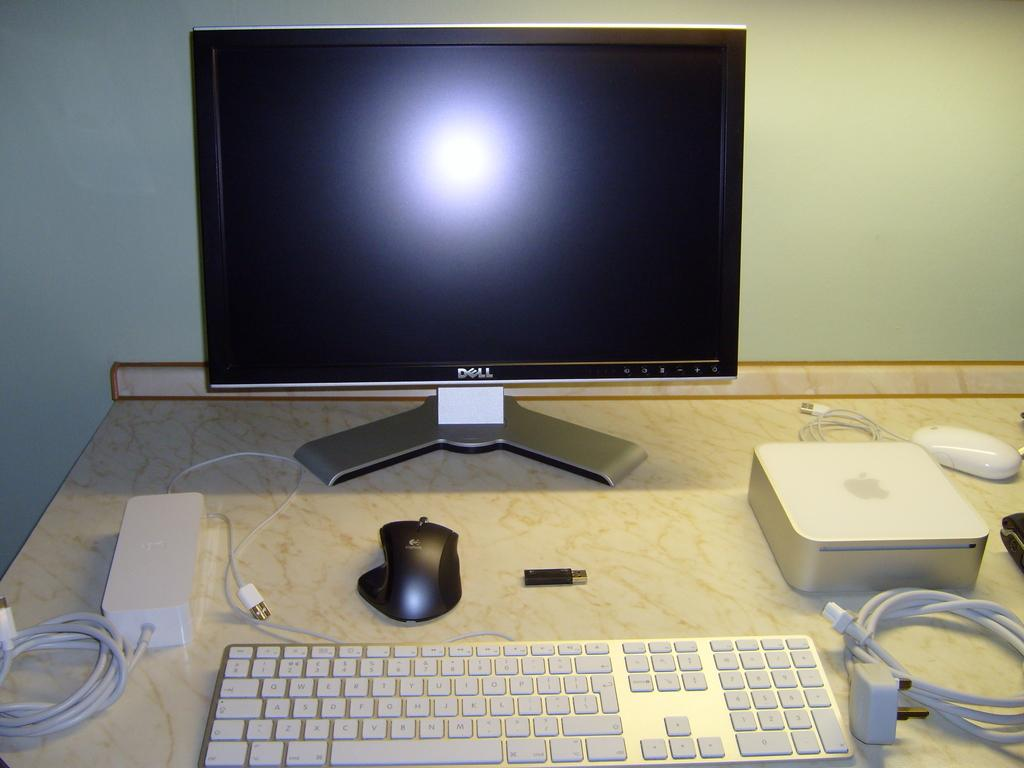<image>
Describe the image concisely. A keyboard, mouse and other computer devices sit on a desk before a blank Dell monitor. 